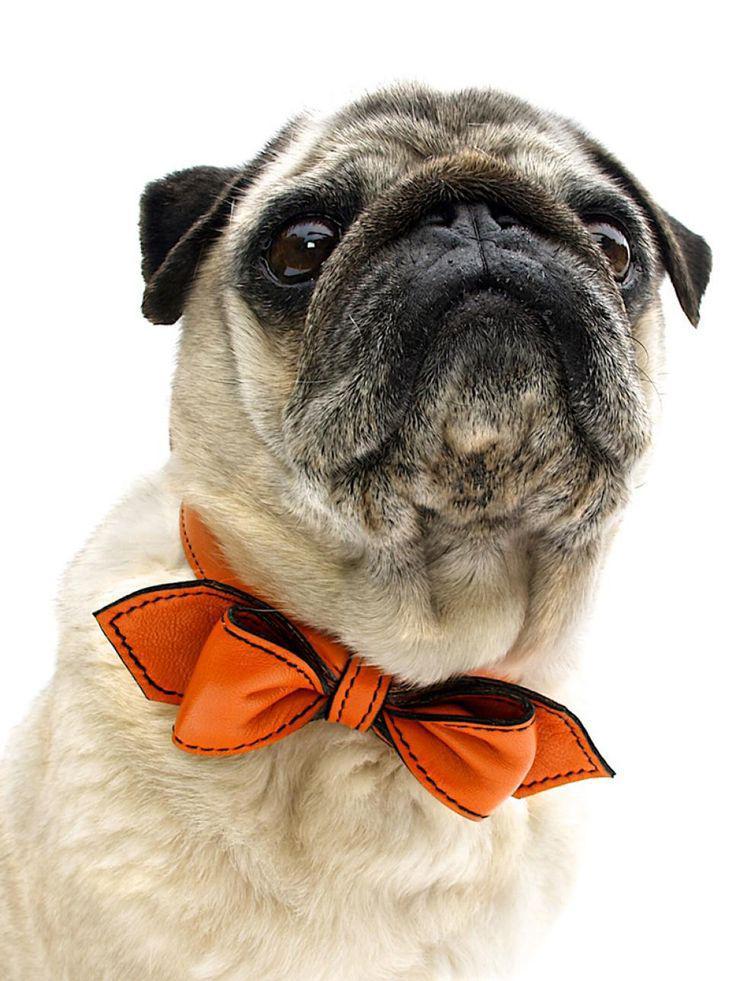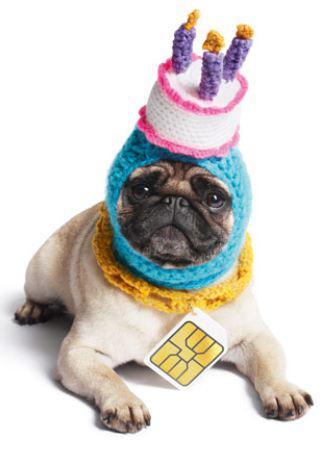The first image is the image on the left, the second image is the image on the right. Examine the images to the left and right. Is the description "All dogs shown are buff-beige pugs with closed mouths, and one pug is pictured with a cake image by its face." accurate? Answer yes or no. Yes. The first image is the image on the left, the second image is the image on the right. Evaluate the accuracy of this statement regarding the images: "The right image contains three pug dogs.". Is it true? Answer yes or no. No. 